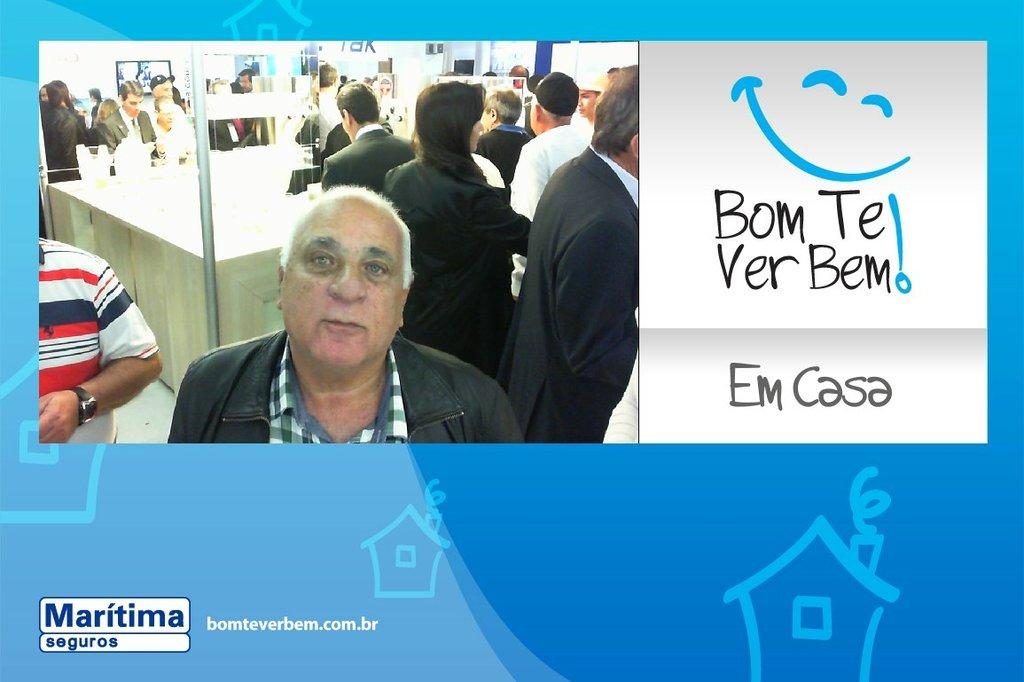<image>
Relay a brief, clear account of the picture shown. A picture of a man next to a sign that says Bom Te Ver Bem  Em Casa . 